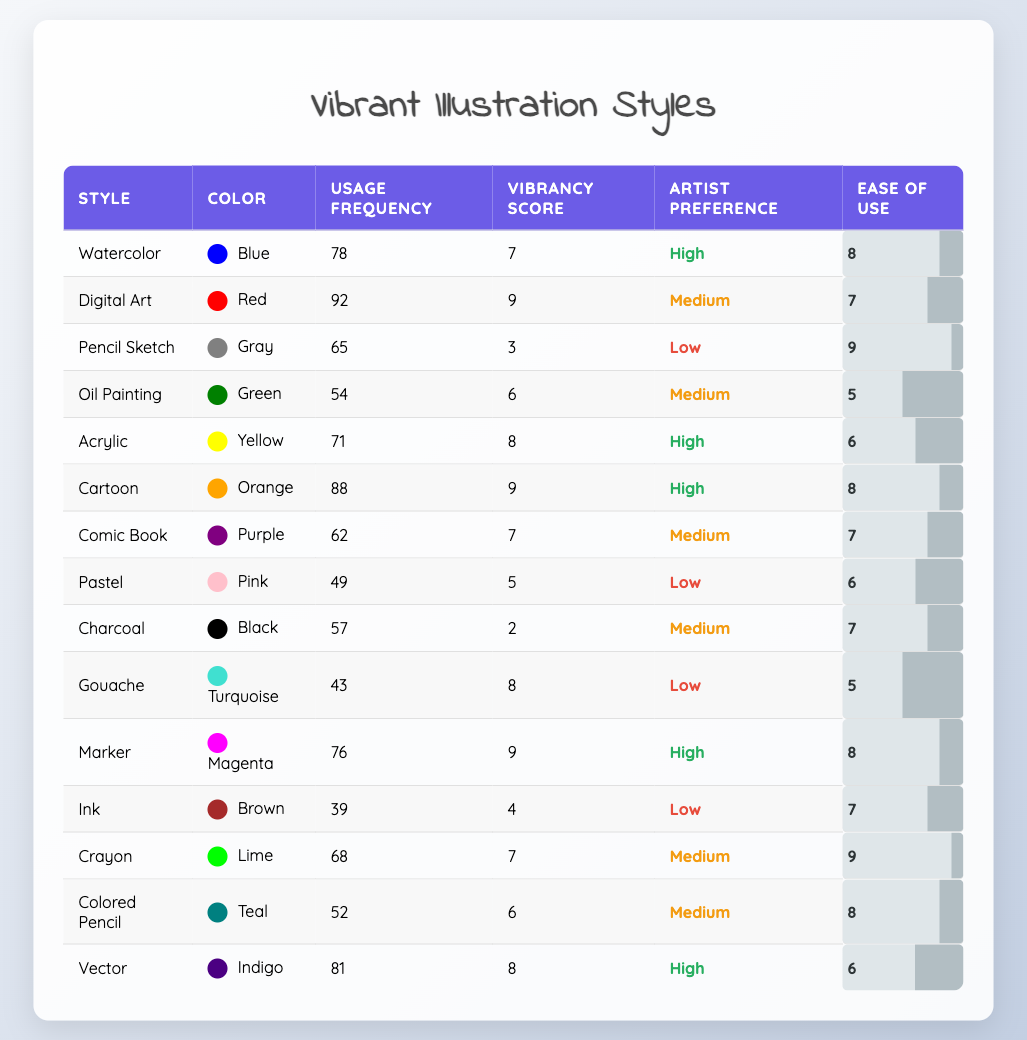What style has the highest usage frequency? By scanning through the "Usage Frequency" column, I see that "Digital Art" has the highest value of 92.
Answer: Digital Art What is the vibrancy score of the "Cartoon" style? Checking the "Vibrancy Score" column for the "Cartoon" style, it shows a score of 9.
Answer: 9 Which styles have a high artist preference? I look through the "Artist Preference" column and find "Watercolor", "Acrylic", "Cartoon", "Marker", and "Vector" all marked as "High".
Answer: Watercolor, Acrylic, Cartoon, Marker, Vector What is the average usage frequency of styles with a low artist preference? The styles with a low artist preference are "Pencil Sketch", "Pastel", "Gouache", and "Ink", which have usage frequencies of 65, 49, 43, and 39 respectively. Summing these gives: 65 + 49 + 43 + 39 = 196. There are 4 styles, so dividing 196 by 4 gives an average of 49.
Answer: 49 Is the vibrancy score of "Digital Art" greater than the average vibrancy score of all styles? First, I find the vibrancy score of "Digital Art", which is 9. To find the average, I sum all vibrancy scores (7 + 9 + 3 + 6 + 8 + 9 + 7 + 5 + 2 + 8 + 9 + 4 + 7 + 6 + 8) = 107, and divide by the total number of styles (15), giving an average of about 7.13. Since 9 is greater than 7.13, the statement is true.
Answer: Yes Which color appears most frequently across all styles? By scanning through the "Color" column, I note each color's usage and see that no colors are repeated, so each color appears only once across different styles.
Answer: Each color appears once 